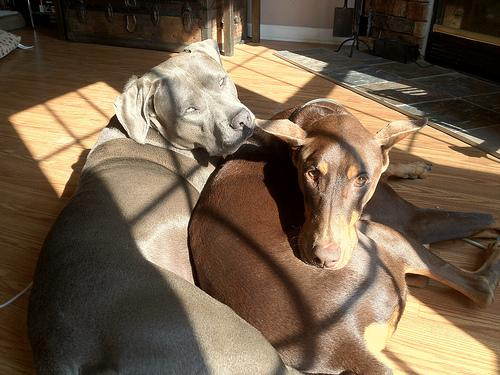Question: why are the dogs laying there?
Choices:
A. It's cool.
B. They are tired.
C. They are sick.
D. It is sunny.
Answer with the letter. Answer: D Question: how many dogs are shown?
Choices:
A. Three.
B. Two.
C. Four.
D. Eight.
Answer with the letter. Answer: B Question: how many dogs are looking at the camera?
Choices:
A. One.
B. Two.
C. Eight.
D. Three.
Answer with the letter. Answer: B Question: what colors are the dogs?
Choices:
A. Grey and brown.
B. Black and white.
C. Brown and white.
D. Yellow and white.
Answer with the letter. Answer: A Question: what is behind the dogs?
Choices:
A. A ball.
B. A trunk.
C. A bowl of water.
D. Dog food.
Answer with the letter. Answer: B 